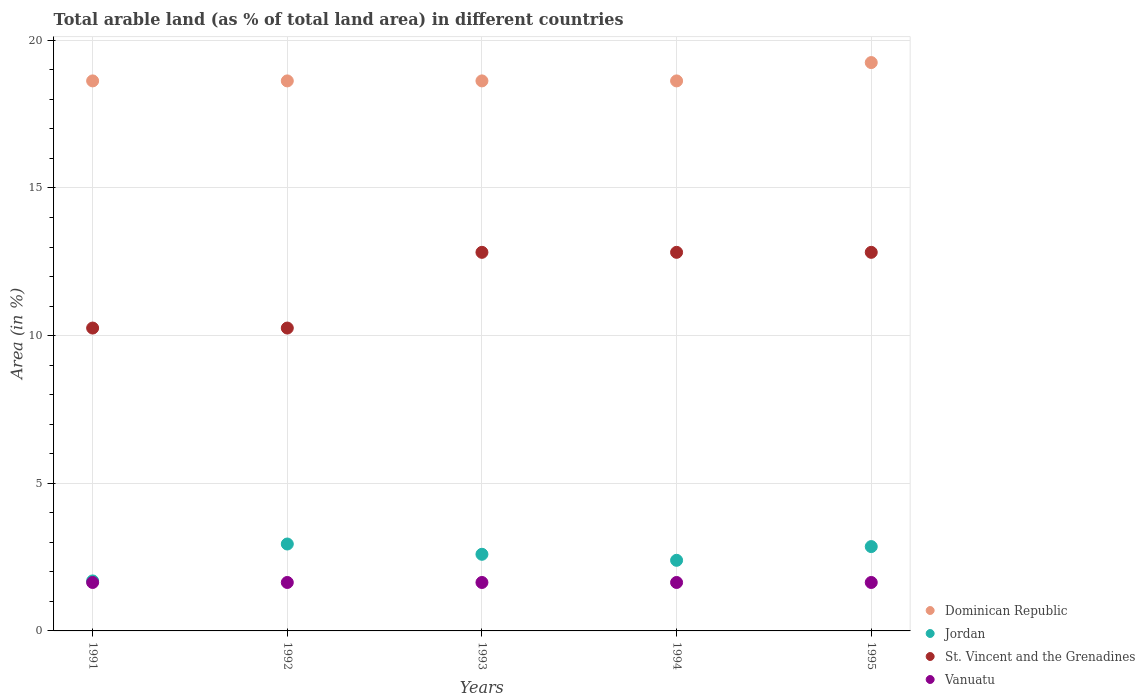How many different coloured dotlines are there?
Offer a terse response. 4. What is the percentage of arable land in Jordan in 1995?
Your answer should be very brief. 2.86. Across all years, what is the maximum percentage of arable land in Dominican Republic?
Provide a short and direct response. 19.25. Across all years, what is the minimum percentage of arable land in Vanuatu?
Your answer should be compact. 1.64. In which year was the percentage of arable land in Vanuatu maximum?
Offer a very short reply. 1991. In which year was the percentage of arable land in Dominican Republic minimum?
Your response must be concise. 1991. What is the total percentage of arable land in Vanuatu in the graph?
Offer a very short reply. 8.2. What is the difference between the percentage of arable land in St. Vincent and the Grenadines in 1991 and the percentage of arable land in Dominican Republic in 1992?
Your answer should be very brief. -8.37. What is the average percentage of arable land in Dominican Republic per year?
Your response must be concise. 18.75. In the year 1992, what is the difference between the percentage of arable land in Dominican Republic and percentage of arable land in Vanuatu?
Keep it short and to the point. 16.99. What is the difference between the highest and the second highest percentage of arable land in Jordan?
Keep it short and to the point. 0.09. In how many years, is the percentage of arable land in Vanuatu greater than the average percentage of arable land in Vanuatu taken over all years?
Your answer should be very brief. 0. Is the sum of the percentage of arable land in Jordan in 1991 and 1993 greater than the maximum percentage of arable land in Dominican Republic across all years?
Keep it short and to the point. No. Is it the case that in every year, the sum of the percentage of arable land in Dominican Republic and percentage of arable land in St. Vincent and the Grenadines  is greater than the sum of percentage of arable land in Vanuatu and percentage of arable land in Jordan?
Keep it short and to the point. Yes. Does the percentage of arable land in St. Vincent and the Grenadines monotonically increase over the years?
Give a very brief answer. No. Is the percentage of arable land in Dominican Republic strictly greater than the percentage of arable land in St. Vincent and the Grenadines over the years?
Ensure brevity in your answer.  Yes. Is the percentage of arable land in St. Vincent and the Grenadines strictly less than the percentage of arable land in Vanuatu over the years?
Give a very brief answer. No. How many years are there in the graph?
Offer a terse response. 5. Does the graph contain grids?
Your answer should be compact. Yes. What is the title of the graph?
Provide a short and direct response. Total arable land (as % of total land area) in different countries. Does "Nigeria" appear as one of the legend labels in the graph?
Your response must be concise. No. What is the label or title of the X-axis?
Ensure brevity in your answer.  Years. What is the label or title of the Y-axis?
Provide a short and direct response. Area (in %). What is the Area (in %) of Dominican Republic in 1991?
Ensure brevity in your answer.  18.63. What is the Area (in %) in Jordan in 1991?
Provide a succinct answer. 1.69. What is the Area (in %) of St. Vincent and the Grenadines in 1991?
Offer a very short reply. 10.26. What is the Area (in %) of Vanuatu in 1991?
Provide a succinct answer. 1.64. What is the Area (in %) in Dominican Republic in 1992?
Give a very brief answer. 18.63. What is the Area (in %) of Jordan in 1992?
Your response must be concise. 2.94. What is the Area (in %) in St. Vincent and the Grenadines in 1992?
Provide a short and direct response. 10.26. What is the Area (in %) in Vanuatu in 1992?
Keep it short and to the point. 1.64. What is the Area (in %) of Dominican Republic in 1993?
Give a very brief answer. 18.63. What is the Area (in %) in Jordan in 1993?
Your response must be concise. 2.6. What is the Area (in %) in St. Vincent and the Grenadines in 1993?
Keep it short and to the point. 12.82. What is the Area (in %) in Vanuatu in 1993?
Your answer should be compact. 1.64. What is the Area (in %) of Dominican Republic in 1994?
Provide a short and direct response. 18.63. What is the Area (in %) of Jordan in 1994?
Your answer should be very brief. 2.39. What is the Area (in %) in St. Vincent and the Grenadines in 1994?
Ensure brevity in your answer.  12.82. What is the Area (in %) in Vanuatu in 1994?
Offer a terse response. 1.64. What is the Area (in %) of Dominican Republic in 1995?
Keep it short and to the point. 19.25. What is the Area (in %) in Jordan in 1995?
Provide a succinct answer. 2.86. What is the Area (in %) in St. Vincent and the Grenadines in 1995?
Offer a very short reply. 12.82. What is the Area (in %) of Vanuatu in 1995?
Offer a terse response. 1.64. Across all years, what is the maximum Area (in %) of Dominican Republic?
Provide a succinct answer. 19.25. Across all years, what is the maximum Area (in %) in Jordan?
Your response must be concise. 2.94. Across all years, what is the maximum Area (in %) of St. Vincent and the Grenadines?
Ensure brevity in your answer.  12.82. Across all years, what is the maximum Area (in %) in Vanuatu?
Give a very brief answer. 1.64. Across all years, what is the minimum Area (in %) of Dominican Republic?
Offer a very short reply. 18.63. Across all years, what is the minimum Area (in %) in Jordan?
Provide a short and direct response. 1.69. Across all years, what is the minimum Area (in %) of St. Vincent and the Grenadines?
Ensure brevity in your answer.  10.26. Across all years, what is the minimum Area (in %) of Vanuatu?
Offer a terse response. 1.64. What is the total Area (in %) in Dominican Republic in the graph?
Your answer should be compact. 93.75. What is the total Area (in %) of Jordan in the graph?
Provide a short and direct response. 12.48. What is the total Area (in %) of St. Vincent and the Grenadines in the graph?
Provide a succinct answer. 58.97. What is the total Area (in %) of Vanuatu in the graph?
Provide a succinct answer. 8.2. What is the difference between the Area (in %) in Jordan in 1991 and that in 1992?
Make the answer very short. -1.25. What is the difference between the Area (in %) of St. Vincent and the Grenadines in 1991 and that in 1992?
Keep it short and to the point. 0. What is the difference between the Area (in %) of Dominican Republic in 1991 and that in 1993?
Provide a short and direct response. 0. What is the difference between the Area (in %) in Jordan in 1991 and that in 1993?
Provide a short and direct response. -0.9. What is the difference between the Area (in %) in St. Vincent and the Grenadines in 1991 and that in 1993?
Keep it short and to the point. -2.56. What is the difference between the Area (in %) in Vanuatu in 1991 and that in 1993?
Make the answer very short. 0. What is the difference between the Area (in %) of Dominican Republic in 1991 and that in 1994?
Provide a short and direct response. 0. What is the difference between the Area (in %) in Jordan in 1991 and that in 1994?
Offer a very short reply. -0.7. What is the difference between the Area (in %) in St. Vincent and the Grenadines in 1991 and that in 1994?
Make the answer very short. -2.56. What is the difference between the Area (in %) in Vanuatu in 1991 and that in 1994?
Keep it short and to the point. 0. What is the difference between the Area (in %) of Dominican Republic in 1991 and that in 1995?
Provide a short and direct response. -0.62. What is the difference between the Area (in %) of Jordan in 1991 and that in 1995?
Ensure brevity in your answer.  -1.16. What is the difference between the Area (in %) of St. Vincent and the Grenadines in 1991 and that in 1995?
Your response must be concise. -2.56. What is the difference between the Area (in %) of Jordan in 1992 and that in 1993?
Make the answer very short. 0.35. What is the difference between the Area (in %) of St. Vincent and the Grenadines in 1992 and that in 1993?
Ensure brevity in your answer.  -2.56. What is the difference between the Area (in %) of Vanuatu in 1992 and that in 1993?
Your answer should be very brief. 0. What is the difference between the Area (in %) of Jordan in 1992 and that in 1994?
Provide a succinct answer. 0.55. What is the difference between the Area (in %) of St. Vincent and the Grenadines in 1992 and that in 1994?
Give a very brief answer. -2.56. What is the difference between the Area (in %) of Dominican Republic in 1992 and that in 1995?
Provide a succinct answer. -0.62. What is the difference between the Area (in %) of Jordan in 1992 and that in 1995?
Offer a very short reply. 0.09. What is the difference between the Area (in %) of St. Vincent and the Grenadines in 1992 and that in 1995?
Make the answer very short. -2.56. What is the difference between the Area (in %) of Dominican Republic in 1993 and that in 1994?
Your response must be concise. 0. What is the difference between the Area (in %) in Jordan in 1993 and that in 1994?
Your answer should be compact. 0.2. What is the difference between the Area (in %) of St. Vincent and the Grenadines in 1993 and that in 1994?
Give a very brief answer. 0. What is the difference between the Area (in %) of Vanuatu in 1993 and that in 1994?
Give a very brief answer. 0. What is the difference between the Area (in %) of Dominican Republic in 1993 and that in 1995?
Your answer should be compact. -0.62. What is the difference between the Area (in %) in Jordan in 1993 and that in 1995?
Your answer should be compact. -0.26. What is the difference between the Area (in %) in Dominican Republic in 1994 and that in 1995?
Keep it short and to the point. -0.62. What is the difference between the Area (in %) in Jordan in 1994 and that in 1995?
Keep it short and to the point. -0.46. What is the difference between the Area (in %) in Vanuatu in 1994 and that in 1995?
Provide a short and direct response. 0. What is the difference between the Area (in %) of Dominican Republic in 1991 and the Area (in %) of Jordan in 1992?
Offer a very short reply. 15.68. What is the difference between the Area (in %) of Dominican Republic in 1991 and the Area (in %) of St. Vincent and the Grenadines in 1992?
Provide a succinct answer. 8.37. What is the difference between the Area (in %) in Dominican Republic in 1991 and the Area (in %) in Vanuatu in 1992?
Your answer should be compact. 16.99. What is the difference between the Area (in %) in Jordan in 1991 and the Area (in %) in St. Vincent and the Grenadines in 1992?
Offer a very short reply. -8.56. What is the difference between the Area (in %) in Jordan in 1991 and the Area (in %) in Vanuatu in 1992?
Provide a short and direct response. 0.05. What is the difference between the Area (in %) of St. Vincent and the Grenadines in 1991 and the Area (in %) of Vanuatu in 1992?
Provide a succinct answer. 8.62. What is the difference between the Area (in %) of Dominican Republic in 1991 and the Area (in %) of Jordan in 1993?
Provide a succinct answer. 16.03. What is the difference between the Area (in %) of Dominican Republic in 1991 and the Area (in %) of St. Vincent and the Grenadines in 1993?
Make the answer very short. 5.81. What is the difference between the Area (in %) of Dominican Republic in 1991 and the Area (in %) of Vanuatu in 1993?
Your answer should be compact. 16.99. What is the difference between the Area (in %) of Jordan in 1991 and the Area (in %) of St. Vincent and the Grenadines in 1993?
Your response must be concise. -11.13. What is the difference between the Area (in %) of Jordan in 1991 and the Area (in %) of Vanuatu in 1993?
Ensure brevity in your answer.  0.05. What is the difference between the Area (in %) in St. Vincent and the Grenadines in 1991 and the Area (in %) in Vanuatu in 1993?
Offer a terse response. 8.62. What is the difference between the Area (in %) in Dominican Republic in 1991 and the Area (in %) in Jordan in 1994?
Keep it short and to the point. 16.23. What is the difference between the Area (in %) of Dominican Republic in 1991 and the Area (in %) of St. Vincent and the Grenadines in 1994?
Provide a succinct answer. 5.81. What is the difference between the Area (in %) of Dominican Republic in 1991 and the Area (in %) of Vanuatu in 1994?
Provide a succinct answer. 16.99. What is the difference between the Area (in %) of Jordan in 1991 and the Area (in %) of St. Vincent and the Grenadines in 1994?
Your answer should be very brief. -11.13. What is the difference between the Area (in %) of Jordan in 1991 and the Area (in %) of Vanuatu in 1994?
Provide a succinct answer. 0.05. What is the difference between the Area (in %) in St. Vincent and the Grenadines in 1991 and the Area (in %) in Vanuatu in 1994?
Your response must be concise. 8.62. What is the difference between the Area (in %) in Dominican Republic in 1991 and the Area (in %) in Jordan in 1995?
Keep it short and to the point. 15.77. What is the difference between the Area (in %) in Dominican Republic in 1991 and the Area (in %) in St. Vincent and the Grenadines in 1995?
Provide a succinct answer. 5.81. What is the difference between the Area (in %) in Dominican Republic in 1991 and the Area (in %) in Vanuatu in 1995?
Offer a very short reply. 16.99. What is the difference between the Area (in %) in Jordan in 1991 and the Area (in %) in St. Vincent and the Grenadines in 1995?
Keep it short and to the point. -11.13. What is the difference between the Area (in %) in Jordan in 1991 and the Area (in %) in Vanuatu in 1995?
Your answer should be very brief. 0.05. What is the difference between the Area (in %) in St. Vincent and the Grenadines in 1991 and the Area (in %) in Vanuatu in 1995?
Keep it short and to the point. 8.62. What is the difference between the Area (in %) of Dominican Republic in 1992 and the Area (in %) of Jordan in 1993?
Provide a short and direct response. 16.03. What is the difference between the Area (in %) in Dominican Republic in 1992 and the Area (in %) in St. Vincent and the Grenadines in 1993?
Your answer should be very brief. 5.81. What is the difference between the Area (in %) in Dominican Republic in 1992 and the Area (in %) in Vanuatu in 1993?
Offer a terse response. 16.99. What is the difference between the Area (in %) of Jordan in 1992 and the Area (in %) of St. Vincent and the Grenadines in 1993?
Your answer should be very brief. -9.88. What is the difference between the Area (in %) of Jordan in 1992 and the Area (in %) of Vanuatu in 1993?
Ensure brevity in your answer.  1.3. What is the difference between the Area (in %) in St. Vincent and the Grenadines in 1992 and the Area (in %) in Vanuatu in 1993?
Your answer should be very brief. 8.62. What is the difference between the Area (in %) in Dominican Republic in 1992 and the Area (in %) in Jordan in 1994?
Ensure brevity in your answer.  16.23. What is the difference between the Area (in %) in Dominican Republic in 1992 and the Area (in %) in St. Vincent and the Grenadines in 1994?
Keep it short and to the point. 5.81. What is the difference between the Area (in %) in Dominican Republic in 1992 and the Area (in %) in Vanuatu in 1994?
Make the answer very short. 16.99. What is the difference between the Area (in %) in Jordan in 1992 and the Area (in %) in St. Vincent and the Grenadines in 1994?
Make the answer very short. -9.88. What is the difference between the Area (in %) in Jordan in 1992 and the Area (in %) in Vanuatu in 1994?
Your response must be concise. 1.3. What is the difference between the Area (in %) in St. Vincent and the Grenadines in 1992 and the Area (in %) in Vanuatu in 1994?
Offer a terse response. 8.62. What is the difference between the Area (in %) of Dominican Republic in 1992 and the Area (in %) of Jordan in 1995?
Your response must be concise. 15.77. What is the difference between the Area (in %) of Dominican Republic in 1992 and the Area (in %) of St. Vincent and the Grenadines in 1995?
Your response must be concise. 5.81. What is the difference between the Area (in %) in Dominican Republic in 1992 and the Area (in %) in Vanuatu in 1995?
Provide a succinct answer. 16.99. What is the difference between the Area (in %) in Jordan in 1992 and the Area (in %) in St. Vincent and the Grenadines in 1995?
Offer a terse response. -9.88. What is the difference between the Area (in %) in Jordan in 1992 and the Area (in %) in Vanuatu in 1995?
Make the answer very short. 1.3. What is the difference between the Area (in %) in St. Vincent and the Grenadines in 1992 and the Area (in %) in Vanuatu in 1995?
Offer a terse response. 8.62. What is the difference between the Area (in %) in Dominican Republic in 1993 and the Area (in %) in Jordan in 1994?
Your answer should be very brief. 16.23. What is the difference between the Area (in %) of Dominican Republic in 1993 and the Area (in %) of St. Vincent and the Grenadines in 1994?
Ensure brevity in your answer.  5.81. What is the difference between the Area (in %) of Dominican Republic in 1993 and the Area (in %) of Vanuatu in 1994?
Your answer should be compact. 16.99. What is the difference between the Area (in %) in Jordan in 1993 and the Area (in %) in St. Vincent and the Grenadines in 1994?
Your answer should be very brief. -10.23. What is the difference between the Area (in %) in Jordan in 1993 and the Area (in %) in Vanuatu in 1994?
Ensure brevity in your answer.  0.95. What is the difference between the Area (in %) of St. Vincent and the Grenadines in 1993 and the Area (in %) of Vanuatu in 1994?
Offer a terse response. 11.18. What is the difference between the Area (in %) in Dominican Republic in 1993 and the Area (in %) in Jordan in 1995?
Provide a short and direct response. 15.77. What is the difference between the Area (in %) in Dominican Republic in 1993 and the Area (in %) in St. Vincent and the Grenadines in 1995?
Make the answer very short. 5.81. What is the difference between the Area (in %) of Dominican Republic in 1993 and the Area (in %) of Vanuatu in 1995?
Offer a terse response. 16.99. What is the difference between the Area (in %) of Jordan in 1993 and the Area (in %) of St. Vincent and the Grenadines in 1995?
Make the answer very short. -10.23. What is the difference between the Area (in %) of Jordan in 1993 and the Area (in %) of Vanuatu in 1995?
Provide a succinct answer. 0.95. What is the difference between the Area (in %) in St. Vincent and the Grenadines in 1993 and the Area (in %) in Vanuatu in 1995?
Provide a succinct answer. 11.18. What is the difference between the Area (in %) of Dominican Republic in 1994 and the Area (in %) of Jordan in 1995?
Give a very brief answer. 15.77. What is the difference between the Area (in %) in Dominican Republic in 1994 and the Area (in %) in St. Vincent and the Grenadines in 1995?
Your answer should be very brief. 5.81. What is the difference between the Area (in %) of Dominican Republic in 1994 and the Area (in %) of Vanuatu in 1995?
Your answer should be very brief. 16.99. What is the difference between the Area (in %) in Jordan in 1994 and the Area (in %) in St. Vincent and the Grenadines in 1995?
Make the answer very short. -10.43. What is the difference between the Area (in %) of Jordan in 1994 and the Area (in %) of Vanuatu in 1995?
Your answer should be very brief. 0.75. What is the difference between the Area (in %) of St. Vincent and the Grenadines in 1994 and the Area (in %) of Vanuatu in 1995?
Your answer should be compact. 11.18. What is the average Area (in %) of Dominican Republic per year?
Your response must be concise. 18.75. What is the average Area (in %) in Jordan per year?
Offer a terse response. 2.5. What is the average Area (in %) of St. Vincent and the Grenadines per year?
Offer a very short reply. 11.79. What is the average Area (in %) of Vanuatu per year?
Provide a short and direct response. 1.64. In the year 1991, what is the difference between the Area (in %) in Dominican Republic and Area (in %) in Jordan?
Offer a terse response. 16.93. In the year 1991, what is the difference between the Area (in %) in Dominican Republic and Area (in %) in St. Vincent and the Grenadines?
Offer a terse response. 8.37. In the year 1991, what is the difference between the Area (in %) of Dominican Republic and Area (in %) of Vanuatu?
Ensure brevity in your answer.  16.99. In the year 1991, what is the difference between the Area (in %) of Jordan and Area (in %) of St. Vincent and the Grenadines?
Your answer should be very brief. -8.56. In the year 1991, what is the difference between the Area (in %) in Jordan and Area (in %) in Vanuatu?
Your response must be concise. 0.05. In the year 1991, what is the difference between the Area (in %) of St. Vincent and the Grenadines and Area (in %) of Vanuatu?
Give a very brief answer. 8.62. In the year 1992, what is the difference between the Area (in %) in Dominican Republic and Area (in %) in Jordan?
Give a very brief answer. 15.68. In the year 1992, what is the difference between the Area (in %) of Dominican Republic and Area (in %) of St. Vincent and the Grenadines?
Provide a succinct answer. 8.37. In the year 1992, what is the difference between the Area (in %) of Dominican Republic and Area (in %) of Vanuatu?
Offer a very short reply. 16.99. In the year 1992, what is the difference between the Area (in %) of Jordan and Area (in %) of St. Vincent and the Grenadines?
Ensure brevity in your answer.  -7.31. In the year 1992, what is the difference between the Area (in %) in Jordan and Area (in %) in Vanuatu?
Your response must be concise. 1.3. In the year 1992, what is the difference between the Area (in %) in St. Vincent and the Grenadines and Area (in %) in Vanuatu?
Your response must be concise. 8.62. In the year 1993, what is the difference between the Area (in %) in Dominican Republic and Area (in %) in Jordan?
Offer a very short reply. 16.03. In the year 1993, what is the difference between the Area (in %) in Dominican Republic and Area (in %) in St. Vincent and the Grenadines?
Provide a succinct answer. 5.81. In the year 1993, what is the difference between the Area (in %) of Dominican Republic and Area (in %) of Vanuatu?
Your response must be concise. 16.99. In the year 1993, what is the difference between the Area (in %) in Jordan and Area (in %) in St. Vincent and the Grenadines?
Keep it short and to the point. -10.23. In the year 1993, what is the difference between the Area (in %) in Jordan and Area (in %) in Vanuatu?
Make the answer very short. 0.95. In the year 1993, what is the difference between the Area (in %) in St. Vincent and the Grenadines and Area (in %) in Vanuatu?
Provide a succinct answer. 11.18. In the year 1994, what is the difference between the Area (in %) of Dominican Republic and Area (in %) of Jordan?
Your response must be concise. 16.23. In the year 1994, what is the difference between the Area (in %) of Dominican Republic and Area (in %) of St. Vincent and the Grenadines?
Your response must be concise. 5.81. In the year 1994, what is the difference between the Area (in %) of Dominican Republic and Area (in %) of Vanuatu?
Offer a terse response. 16.99. In the year 1994, what is the difference between the Area (in %) of Jordan and Area (in %) of St. Vincent and the Grenadines?
Ensure brevity in your answer.  -10.43. In the year 1994, what is the difference between the Area (in %) in Jordan and Area (in %) in Vanuatu?
Offer a very short reply. 0.75. In the year 1994, what is the difference between the Area (in %) in St. Vincent and the Grenadines and Area (in %) in Vanuatu?
Your response must be concise. 11.18. In the year 1995, what is the difference between the Area (in %) in Dominican Republic and Area (in %) in Jordan?
Give a very brief answer. 16.39. In the year 1995, what is the difference between the Area (in %) in Dominican Republic and Area (in %) in St. Vincent and the Grenadines?
Offer a very short reply. 6.43. In the year 1995, what is the difference between the Area (in %) in Dominican Republic and Area (in %) in Vanuatu?
Provide a succinct answer. 17.61. In the year 1995, what is the difference between the Area (in %) of Jordan and Area (in %) of St. Vincent and the Grenadines?
Provide a succinct answer. -9.96. In the year 1995, what is the difference between the Area (in %) in Jordan and Area (in %) in Vanuatu?
Offer a terse response. 1.22. In the year 1995, what is the difference between the Area (in %) of St. Vincent and the Grenadines and Area (in %) of Vanuatu?
Give a very brief answer. 11.18. What is the ratio of the Area (in %) of Dominican Republic in 1991 to that in 1992?
Provide a succinct answer. 1. What is the ratio of the Area (in %) in Jordan in 1991 to that in 1992?
Provide a succinct answer. 0.58. What is the ratio of the Area (in %) in St. Vincent and the Grenadines in 1991 to that in 1992?
Your answer should be very brief. 1. What is the ratio of the Area (in %) in Dominican Republic in 1991 to that in 1993?
Ensure brevity in your answer.  1. What is the ratio of the Area (in %) in Jordan in 1991 to that in 1993?
Ensure brevity in your answer.  0.65. What is the ratio of the Area (in %) of Vanuatu in 1991 to that in 1993?
Provide a succinct answer. 1. What is the ratio of the Area (in %) of Jordan in 1991 to that in 1994?
Make the answer very short. 0.71. What is the ratio of the Area (in %) of St. Vincent and the Grenadines in 1991 to that in 1994?
Give a very brief answer. 0.8. What is the ratio of the Area (in %) in Vanuatu in 1991 to that in 1994?
Keep it short and to the point. 1. What is the ratio of the Area (in %) of Dominican Republic in 1991 to that in 1995?
Offer a very short reply. 0.97. What is the ratio of the Area (in %) of Jordan in 1991 to that in 1995?
Ensure brevity in your answer.  0.59. What is the ratio of the Area (in %) in Jordan in 1992 to that in 1993?
Offer a terse response. 1.13. What is the ratio of the Area (in %) in Vanuatu in 1992 to that in 1993?
Offer a very short reply. 1. What is the ratio of the Area (in %) of Jordan in 1992 to that in 1994?
Ensure brevity in your answer.  1.23. What is the ratio of the Area (in %) of St. Vincent and the Grenadines in 1992 to that in 1994?
Provide a short and direct response. 0.8. What is the ratio of the Area (in %) in Jordan in 1992 to that in 1995?
Ensure brevity in your answer.  1.03. What is the ratio of the Area (in %) of Dominican Republic in 1993 to that in 1994?
Keep it short and to the point. 1. What is the ratio of the Area (in %) of Jordan in 1993 to that in 1994?
Make the answer very short. 1.09. What is the ratio of the Area (in %) of Dominican Republic in 1993 to that in 1995?
Your answer should be very brief. 0.97. What is the ratio of the Area (in %) of Jordan in 1993 to that in 1995?
Ensure brevity in your answer.  0.91. What is the ratio of the Area (in %) in Vanuatu in 1993 to that in 1995?
Your answer should be very brief. 1. What is the ratio of the Area (in %) in Jordan in 1994 to that in 1995?
Keep it short and to the point. 0.84. What is the difference between the highest and the second highest Area (in %) of Dominican Republic?
Offer a terse response. 0.62. What is the difference between the highest and the second highest Area (in %) of Jordan?
Your answer should be very brief. 0.09. What is the difference between the highest and the lowest Area (in %) in Dominican Republic?
Offer a very short reply. 0.62. What is the difference between the highest and the lowest Area (in %) in Jordan?
Your answer should be very brief. 1.25. What is the difference between the highest and the lowest Area (in %) of St. Vincent and the Grenadines?
Provide a short and direct response. 2.56. 